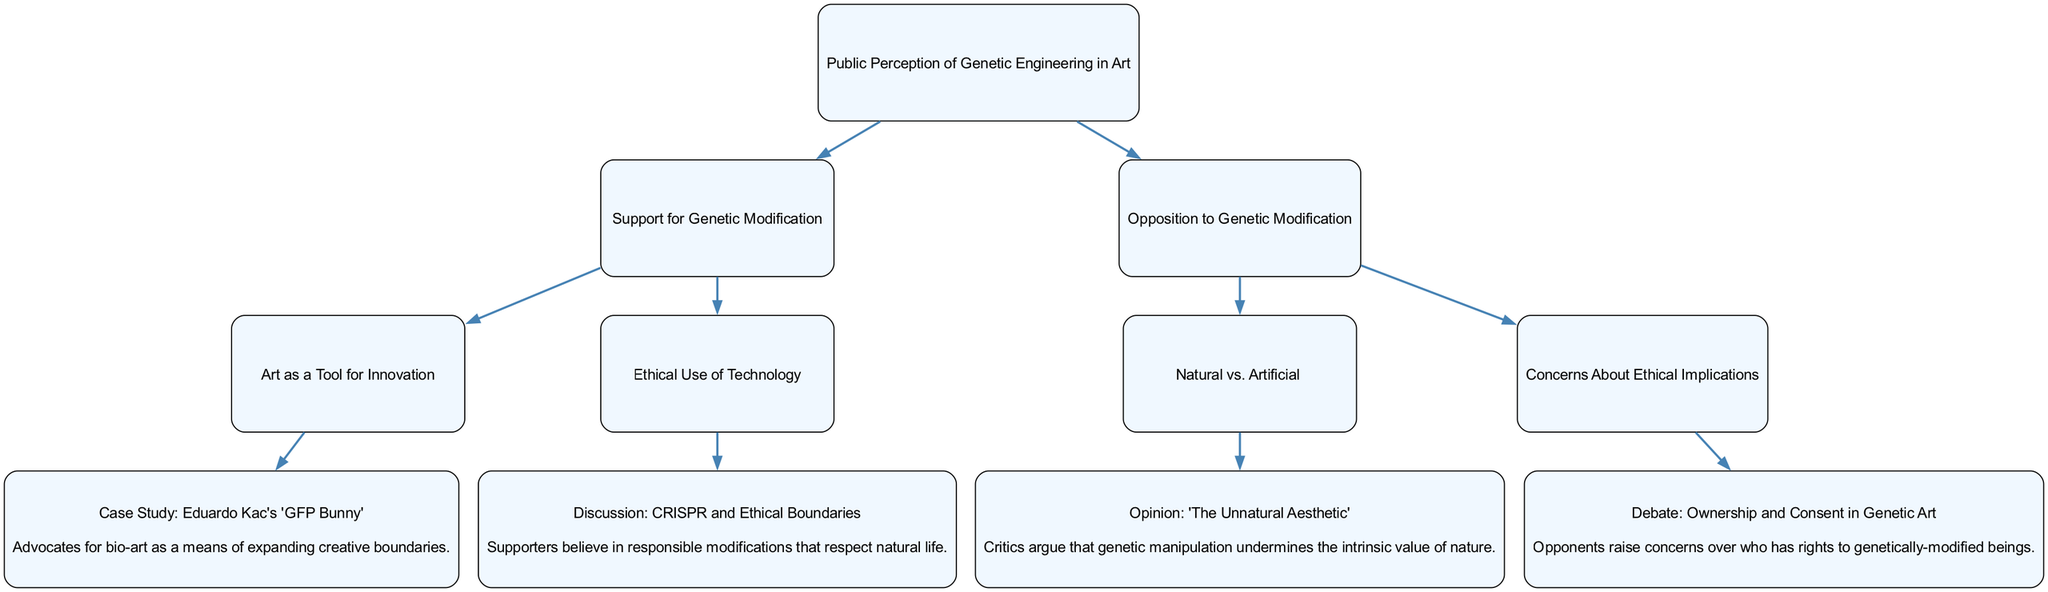What is the primary title of the decision tree? The primary title node of the decision tree is the first node that represents the overall topic being discussed, which relates to public perception and genetic engineering in the context of art.
Answer: Public Perception of Genetic Engineering in Art How many children does the "Support for Genetic Modification" node have? By visually inspecting the "Support for Genetic Modification" node, it can be seen that there are two child nodes connected to it, indicating two main subTopics.
Answer: 2 What are the two main categories of public perception regarding genetic engineering? The decision tree exhibits two main opposing categories: "Support for Genetic Modification" and "Opposition to Genetic Modification," which highlight diverging views on the subject.
Answer: Support for Genetic Modification and Opposition to Genetic Modification What is the case study that advocates for bio-art? Among the children of the "Support for Genetic Modification" node, the case study mentioned illustrates the use of art as a means for innovation, specifically credited to Eduardo Kac and his work, "GFP Bunny."
Answer: Case Study: Eduardo Kac's 'GFP Bunny' Which interpretation describes concerns about ownership and consent in genetic art? The tree identifies a specific debate under the "Concerns About Ethical Implications" node, with an interpretation that explains this concern about rights associated with genetically modified beings.
Answer: Opponents raise concerns over who has rights to genetically-modified beings Which ethical boundary is discussed in relation to CRISPR technology? Under the "Ethical Use of Technology" child node, there is a discussion that reflects on the idea of responsible modifications and the need to respect natural life, directly linked to the implications of CRISPR.
Answer: Supporters believe in responsible modifications that respect natural life What is the perspective associated with the "Natural vs. Artificial" debate? The interpretation given for the "Natural vs. Artificial" node within the opposition suggests that critics hold the view that genetic manipulation reduces nature's intrinsic value, can be summarized from the opinion shared in this section.
Answer: Critics argue that genetic manipulation undermines the intrinsic value of nature How many children does the "Concerns About Ethical Implications" node have? Observing the "Concerns About Ethical Implications" node, we notice it links to a single debate showing that it encompasses one specific discussion focused on ethics in genetic art, indicating one child node.
Answer: 1 